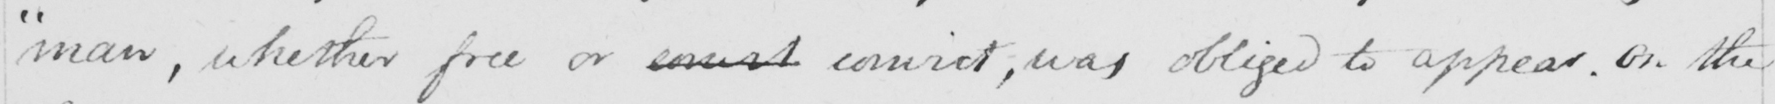Can you tell me what this handwritten text says? " man , whether free or conict convict , was obliged to appear . on the 